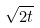<formula> <loc_0><loc_0><loc_500><loc_500>\sqrt { 2 t }</formula> 